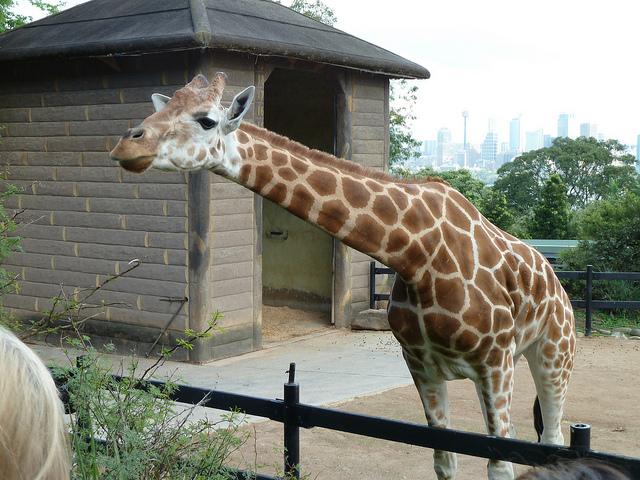What is the giraffe doing?
Answer briefly. Smelling. Are the building in the background in a small town?
Quick response, please. No. What animal is this?
Answer briefly. Giraffe. Is that a baby giraffe?
Give a very brief answer. No. 